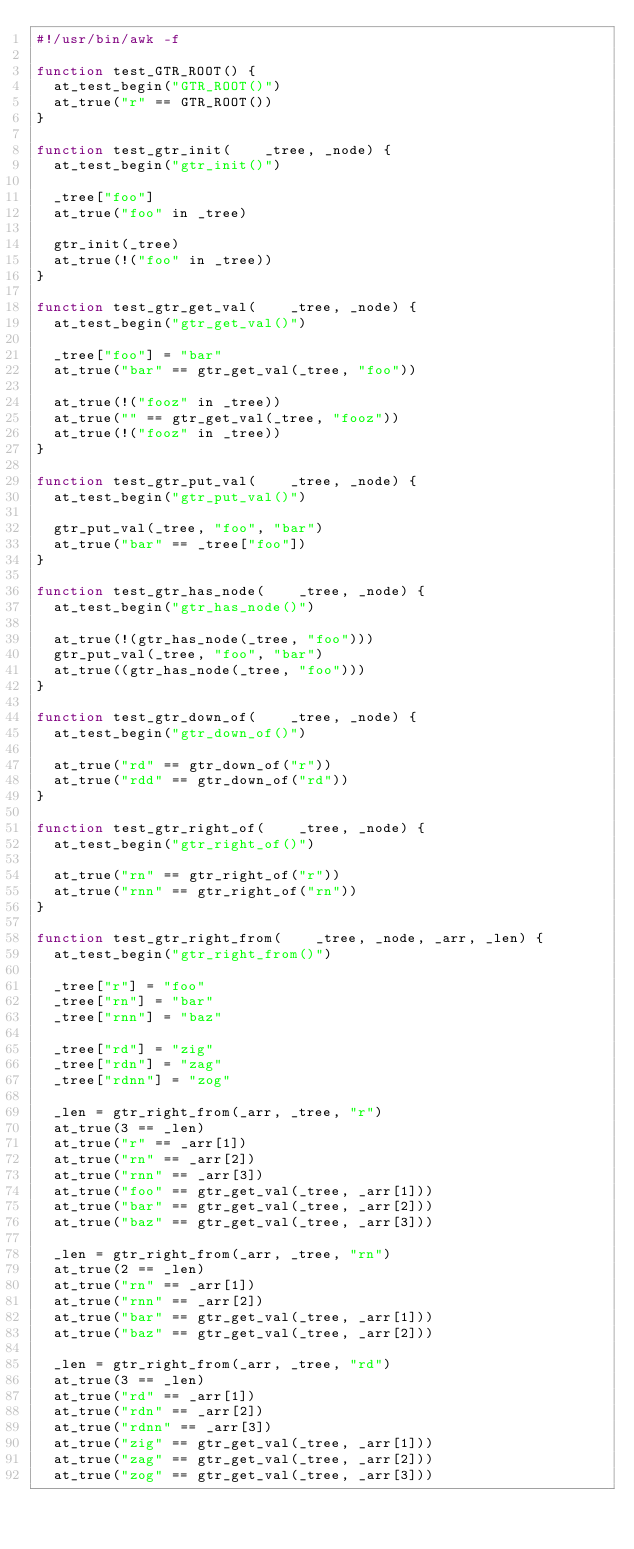<code> <loc_0><loc_0><loc_500><loc_500><_Awk_>#!/usr/bin/awk -f

function test_GTR_ROOT() {
	at_test_begin("GTR_ROOT()")
	at_true("r" == GTR_ROOT())
}

function test_gtr_init(    _tree, _node) {
	at_test_begin("gtr_init()")
	
	_tree["foo"]
	at_true("foo" in _tree)
	
	gtr_init(_tree)
	at_true(!("foo" in _tree))
}

function test_gtr_get_val(    _tree, _node) {
	at_test_begin("gtr_get_val()")
	
	_tree["foo"] = "bar"
	at_true("bar" == gtr_get_val(_tree, "foo"))
	
	at_true(!("fooz" in _tree))
	at_true("" == gtr_get_val(_tree, "fooz"))
	at_true(!("fooz" in _tree))
}

function test_gtr_put_val(    _tree, _node) {
	at_test_begin("gtr_put_val()")

	gtr_put_val(_tree, "foo", "bar")
	at_true("bar" == _tree["foo"])
}

function test_gtr_has_node(    _tree, _node) {
	at_test_begin("gtr_has_node()")

	at_true(!(gtr_has_node(_tree, "foo")))
	gtr_put_val(_tree, "foo", "bar")
	at_true((gtr_has_node(_tree, "foo")))
}

function test_gtr_down_of(    _tree, _node) {
	at_test_begin("gtr_down_of()")
	
	at_true("rd" == gtr_down_of("r"))
	at_true("rdd" == gtr_down_of("rd"))
}

function test_gtr_right_of(    _tree, _node) {
	at_test_begin("gtr_right_of()")
	
	at_true("rn" == gtr_right_of("r"))
	at_true("rnn" == gtr_right_of("rn"))
}

function test_gtr_right_from(    _tree, _node, _arr, _len) {
	at_test_begin("gtr_right_from()")
	
	_tree["r"] = "foo"
	_tree["rn"] = "bar"
	_tree["rnn"] = "baz"

	_tree["rd"] = "zig"
	_tree["rdn"] = "zag"
	_tree["rdnn"] = "zog"

	_len = gtr_right_from(_arr, _tree, "r")
	at_true(3 == _len)
	at_true("r" == _arr[1])
	at_true("rn" == _arr[2])
	at_true("rnn" == _arr[3])
	at_true("foo" == gtr_get_val(_tree, _arr[1]))
	at_true("bar" == gtr_get_val(_tree, _arr[2]))
	at_true("baz" == gtr_get_val(_tree, _arr[3]))

	_len = gtr_right_from(_arr, _tree, "rn")
	at_true(2 == _len)
	at_true("rn" == _arr[1])
	at_true("rnn" == _arr[2])
	at_true("bar" == gtr_get_val(_tree, _arr[1]))
	at_true("baz" == gtr_get_val(_tree, _arr[2]))

	_len = gtr_right_from(_arr, _tree, "rd")
	at_true(3 == _len)
	at_true("rd" == _arr[1])
	at_true("rdn" == _arr[2])
	at_true("rdnn" == _arr[3])
	at_true("zig" == gtr_get_val(_tree, _arr[1]))
	at_true("zag" == gtr_get_val(_tree, _arr[2]))
	at_true("zog" == gtr_get_val(_tree, _arr[3]))
	</code> 